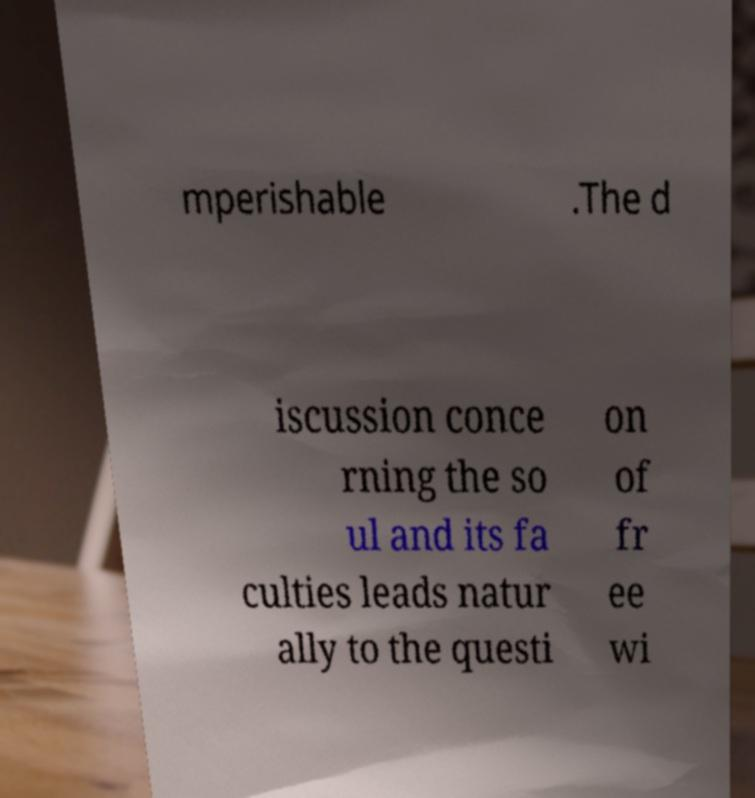Please read and relay the text visible in this image. What does it say? mperishable .The d iscussion conce rning the so ul and its fa culties leads natur ally to the questi on of fr ee wi 